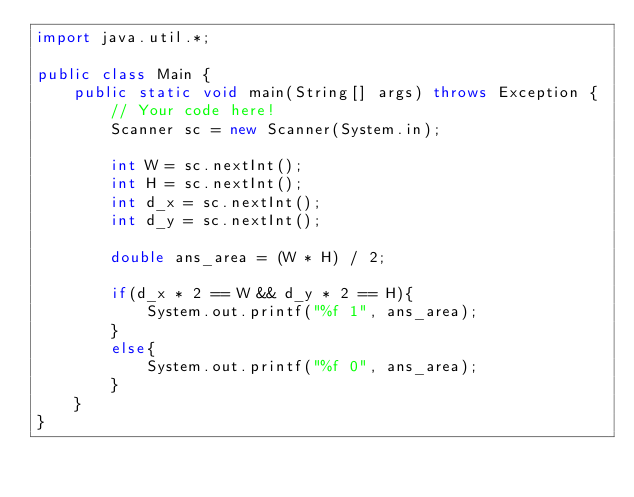<code> <loc_0><loc_0><loc_500><loc_500><_Java_>import java.util.*;

public class Main {
    public static void main(String[] args) throws Exception {
        // Your code here!
        Scanner sc = new Scanner(System.in);
        
        int W = sc.nextInt();
        int H = sc.nextInt();
        int d_x = sc.nextInt();
        int d_y = sc.nextInt();
        
        double ans_area = (W * H) / 2;
        
        if(d_x * 2 == W && d_y * 2 == H){
            System.out.printf("%f 1", ans_area);
        }
        else{
            System.out.printf("%f 0", ans_area);
        }
    }
}
</code> 